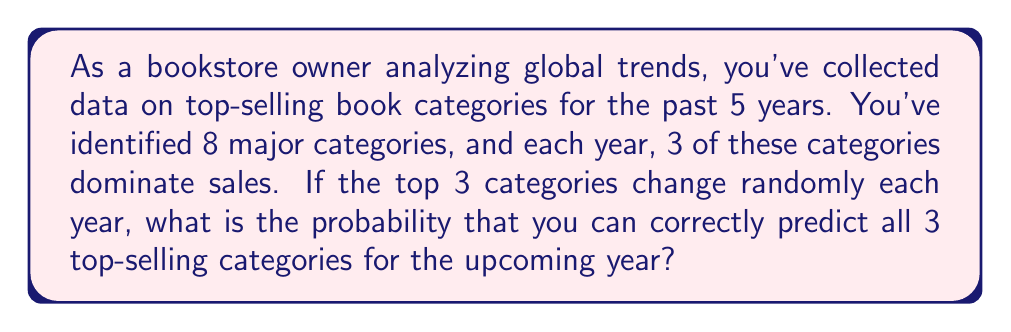Give your solution to this math problem. Let's approach this step-by-step:

1) We need to choose 3 categories out of 8 for our prediction. This is a combination problem.

2) The total number of ways to choose 3 categories out of 8 is given by the combination formula:

   $$\binom{8}{3} = \frac{8!}{3!(8-3)!} = \frac{8!}{3!5!}$$

3) Let's calculate this:
   $$\frac{8 * 7 * 6 * 5!}{(3 * 2 * 1) * 5!} = \frac{336}{6} = 56$$

4) So there are 56 possible combinations of 3 categories we could predict.

5) For our prediction to be correct, the actual top 3 categories must match our prediction exactly. There's only one way for this to happen.

6) The probability of a correct prediction is therefore:

   $$P(\text{correct prediction}) = \frac{\text{favorable outcomes}}{\text{total possible outcomes}} = \frac{1}{56}$$

Thus, the probability of correctly predicting all 3 top-selling categories is $\frac{1}{56}$.
Answer: $\frac{1}{56}$ 